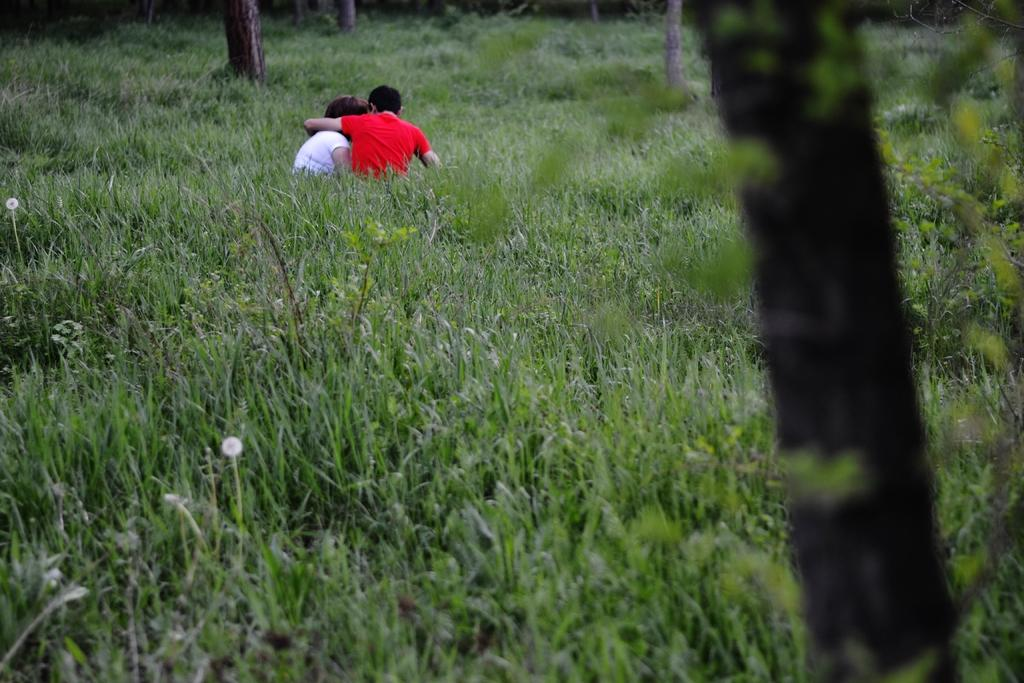How many people are sitting in the image? There are two people sitting on the grass in the image. What type of vegetation is visible at the back of the image? There are trees at the back of the image. What is the surface that the people are sitting on? There is grass at the bottom of the image. What type of flowers can be seen in the image? There are white-colored flowers in the image. Where is the basin located in the image? There is no basin present in the image. What type of cub can be seen playing with the flowers in the image? There is no cub present in the image, and therefore no such activity can be observed. 